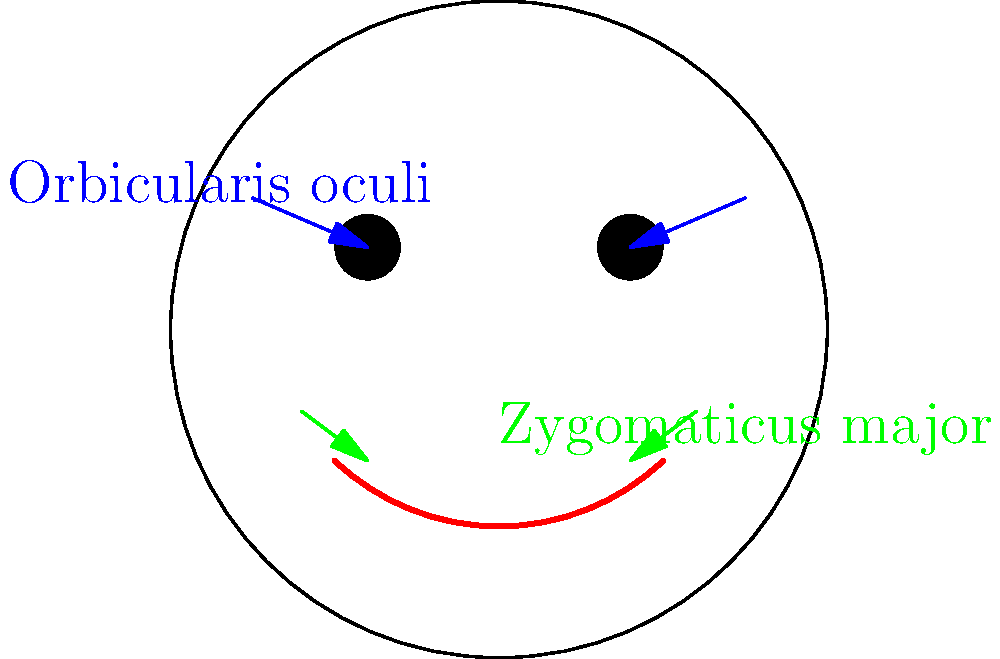In a highly emotional scene where your character needs to express intense joy, which facial muscles would be primarily engaged to create a genuine smile, and how does their activation contribute to the overall expression? To create a genuine smile, also known as a Duchenne smile, two main muscle groups are primarily engaged:

1. Orbicularis oculi:
   - Location: Surrounds the eyes
   - Function: Causes the eyes to crinkle and creates "crow's feet" at the corners
   - Activation: Contracts to narrow the eye opening and raise the cheeks

2. Zygomaticus major:
   - Location: Runs from the cheekbone to the corner of the mouth
   - Function: Pulls the corners of the mouth upwards and outwards
   - Activation: Contracts to create the upward curve of the mouth

The combination of these muscle activations contributes to the overall expression of joy in the following ways:

a) The Orbicularis oculi activation:
   - Makes the smile appear more genuine and spontaneous
   - Increases the perceived intensity of the positive emotion
   - Creates a more engaging and warm appearance

b) The Zygomaticus major activation:
   - Forms the classic "U" shape of the mouth associated with smiling
   - Exposes the teeth, which is often associated with open and positive expressions
   - Pushes the cheeks upward, creating a fuller appearance to the face

c) The synergy between these muscle groups:
   - Creates a harmonious facial expression that appears natural and sincere
   - Engages multiple areas of the face, making the emotion seem more encompassing
   - Produces subtle changes in facial topology that viewers unconsciously recognize as genuine happiness

By understanding and consciously engaging these muscle groups, actors can create more authentic and impactful emotional expressions in their performances, particularly when portraying intense joy in Bollywood films.
Answer: Orbicularis oculi (eye area) and Zygomaticus major (mouth corners) 